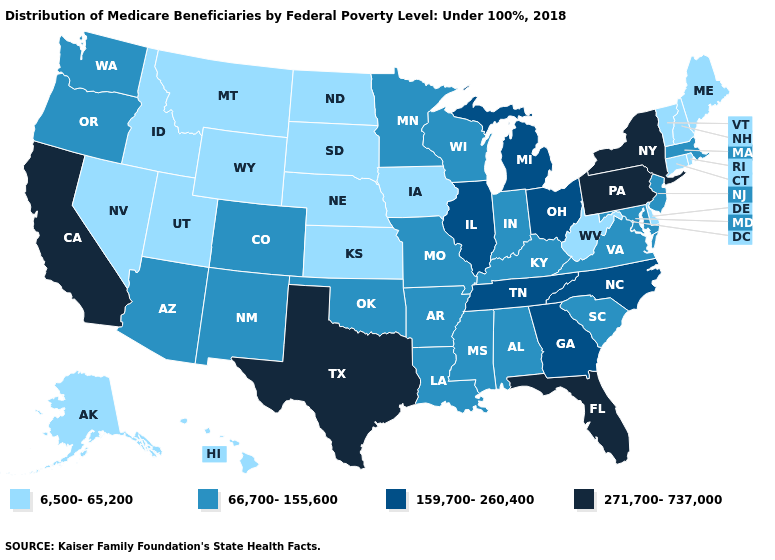Does the map have missing data?
Answer briefly. No. Name the states that have a value in the range 271,700-737,000?
Write a very short answer. California, Florida, New York, Pennsylvania, Texas. Name the states that have a value in the range 159,700-260,400?
Be succinct. Georgia, Illinois, Michigan, North Carolina, Ohio, Tennessee. What is the value of Alabama?
Quick response, please. 66,700-155,600. Does New Mexico have the same value as Arkansas?
Quick response, please. Yes. What is the lowest value in the South?
Quick response, please. 6,500-65,200. Name the states that have a value in the range 271,700-737,000?
Keep it brief. California, Florida, New York, Pennsylvania, Texas. What is the value of Wisconsin?
Quick response, please. 66,700-155,600. What is the highest value in the USA?
Quick response, please. 271,700-737,000. What is the highest value in the USA?
Quick response, please. 271,700-737,000. Name the states that have a value in the range 66,700-155,600?
Short answer required. Alabama, Arizona, Arkansas, Colorado, Indiana, Kentucky, Louisiana, Maryland, Massachusetts, Minnesota, Mississippi, Missouri, New Jersey, New Mexico, Oklahoma, Oregon, South Carolina, Virginia, Washington, Wisconsin. How many symbols are there in the legend?
Write a very short answer. 4. Does Tennessee have the same value as North Carolina?
Be succinct. Yes. Among the states that border South Dakota , does Wyoming have the highest value?
Be succinct. No. Which states have the lowest value in the USA?
Concise answer only. Alaska, Connecticut, Delaware, Hawaii, Idaho, Iowa, Kansas, Maine, Montana, Nebraska, Nevada, New Hampshire, North Dakota, Rhode Island, South Dakota, Utah, Vermont, West Virginia, Wyoming. 